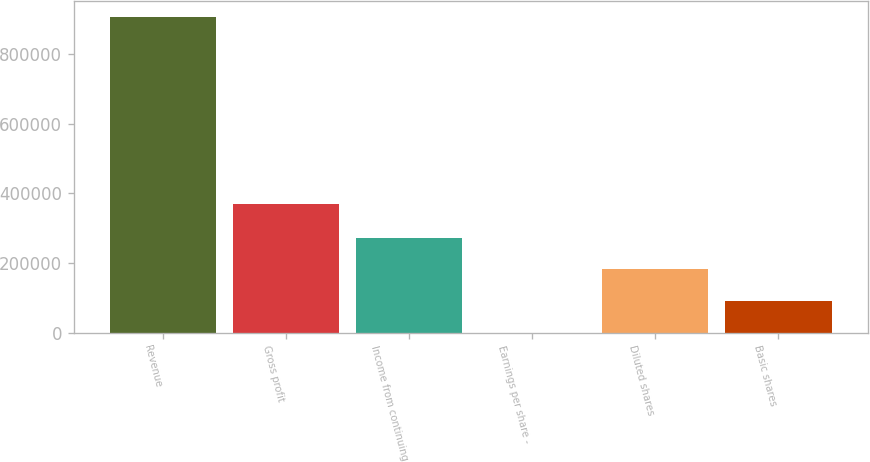Convert chart. <chart><loc_0><loc_0><loc_500><loc_500><bar_chart><fcel>Revenue<fcel>Gross profit<fcel>Income from continuing<fcel>Earnings per share -<fcel>Diluted shares<fcel>Basic shares<nl><fcel>906078<fcel>370474<fcel>271824<fcel>1.34<fcel>181217<fcel>90609<nl></chart> 